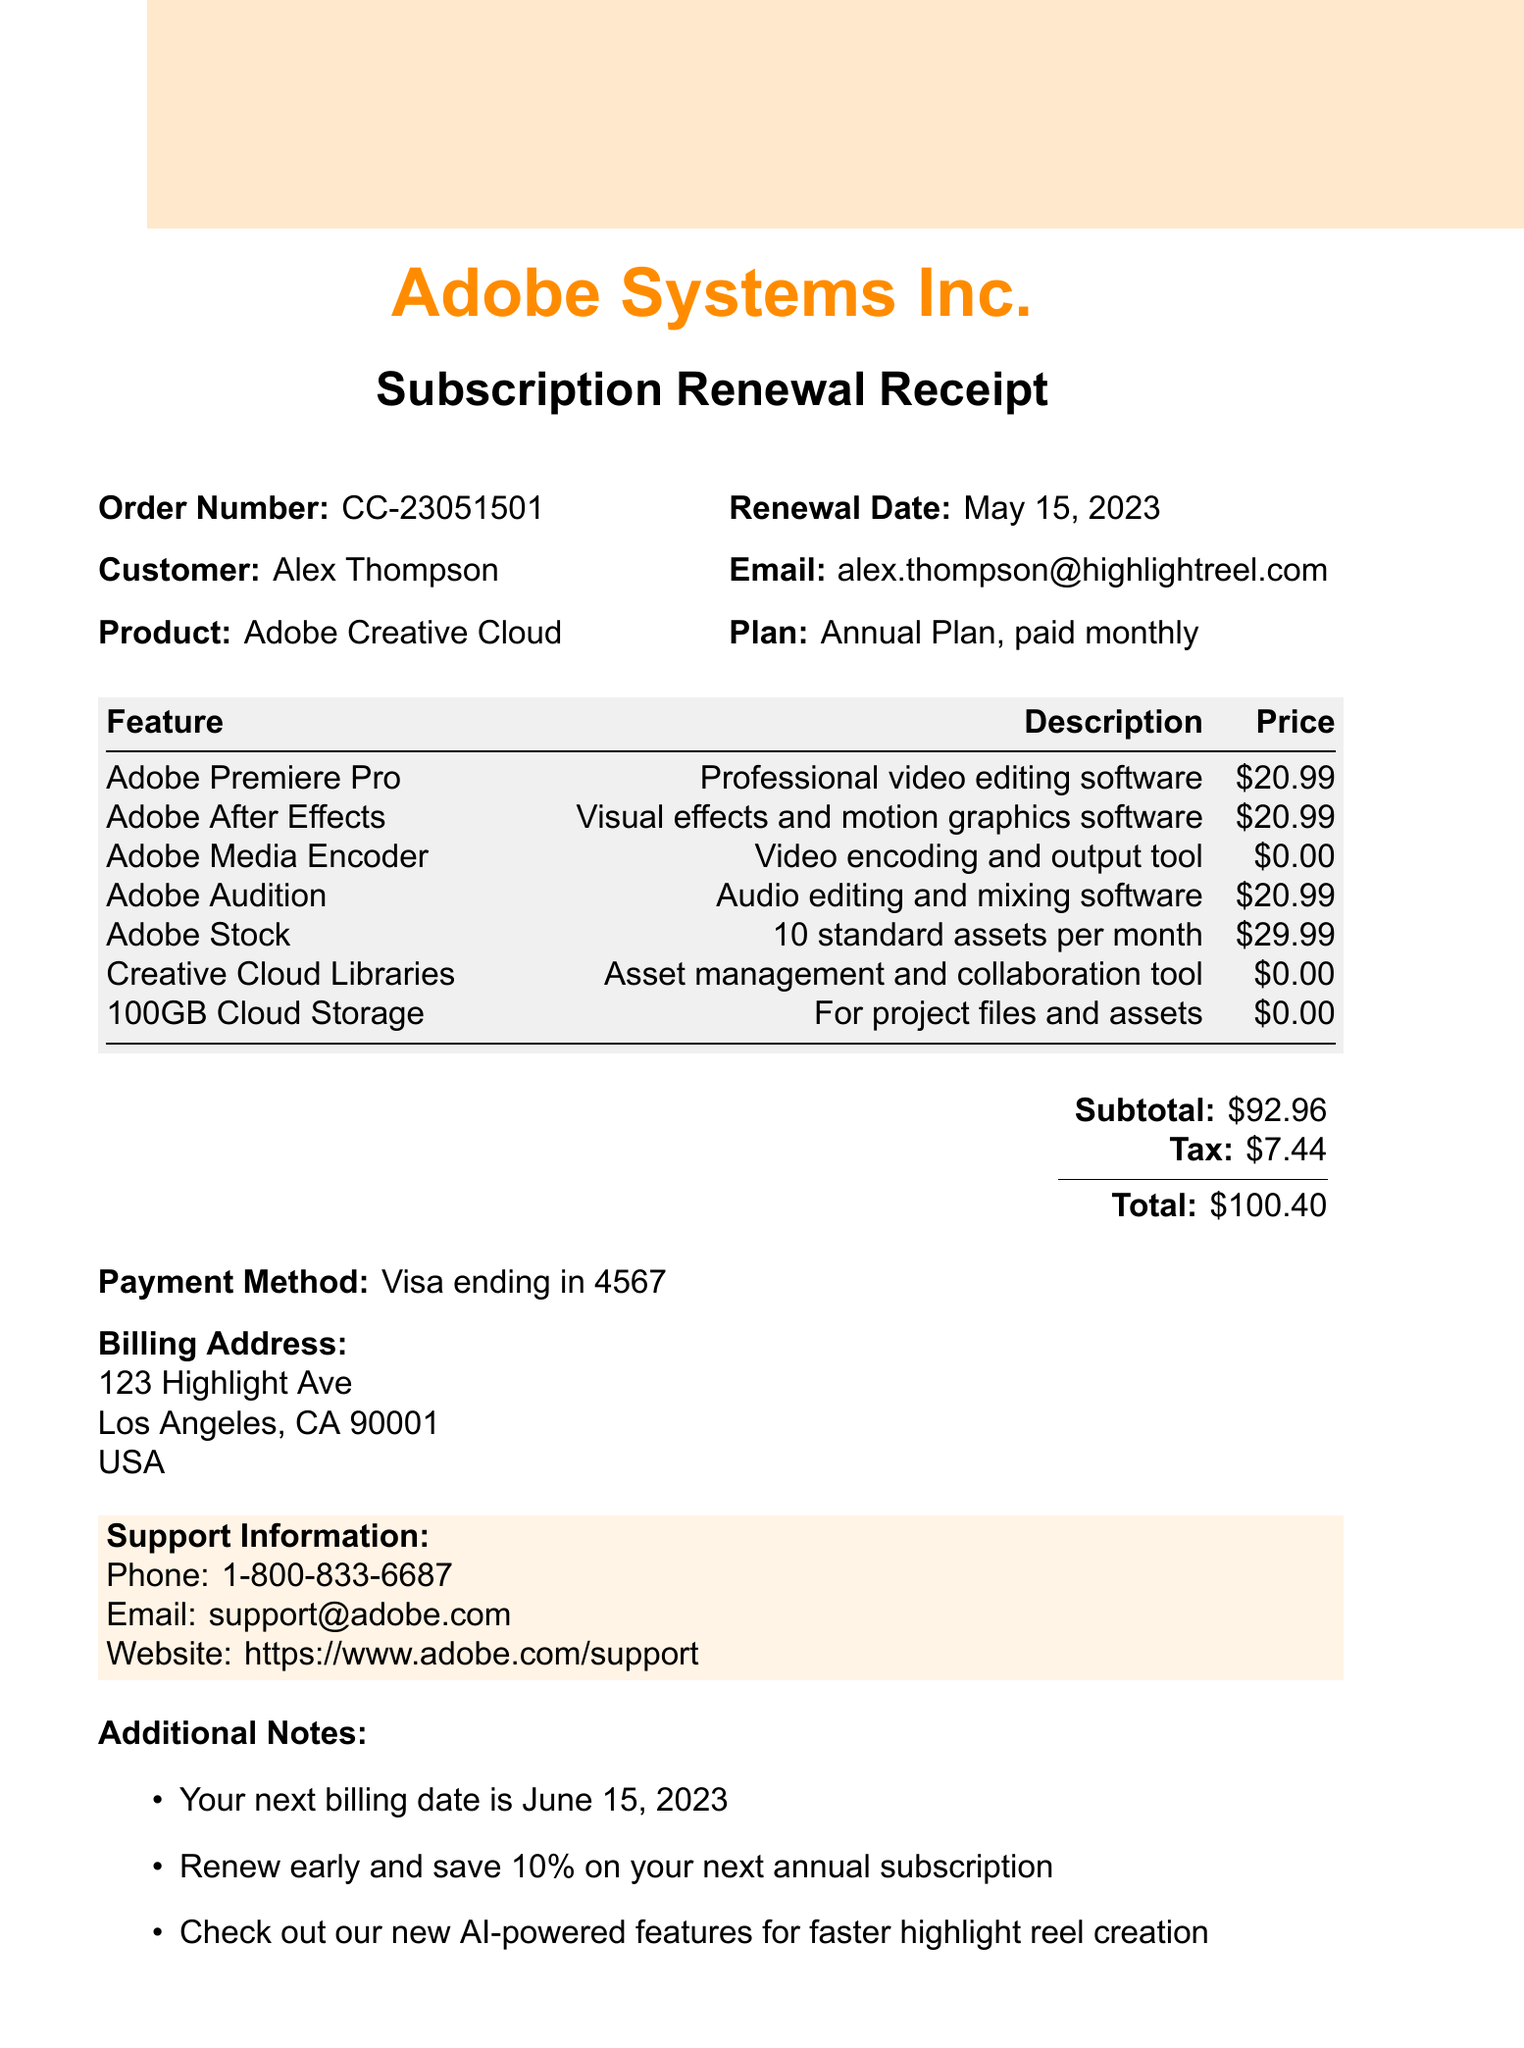What is the company name? The company name is clearly stated at the top of the document.
Answer: Adobe Systems Inc What is the renewal date? The renewal date is indicated next to the order number in the document.
Answer: May 15, 2023 Who is the customer? The customer's name is listed prominently in the order details section.
Answer: Alex Thompson What is the total amount charged? The total amount is calculated and presented in the pricing section of the document.
Answer: $100.40 What features are included in the subscription plan? The features are itemized in a table format within the document.
Answer: Adobe Premiere Pro, Adobe After Effects, Adobe Media Encoder, Adobe Audition, Adobe Stock, Creative Cloud Libraries, 100GB Cloud Storage What is the subtotal before tax? The subtotal is provided in the pricing section before the tax is added.
Answer: $92.96 How much is charged for Adobe Media Encoder? The price for Adobe Media Encoder is listed in the itemized features.
Answer: $0.00 What is the next billing date? The next billing date is mentioned in the additional notes section.
Answer: June 15, 2023 What payment method was used? The payment method is specified in the document.
Answer: Visa ending in 4567 